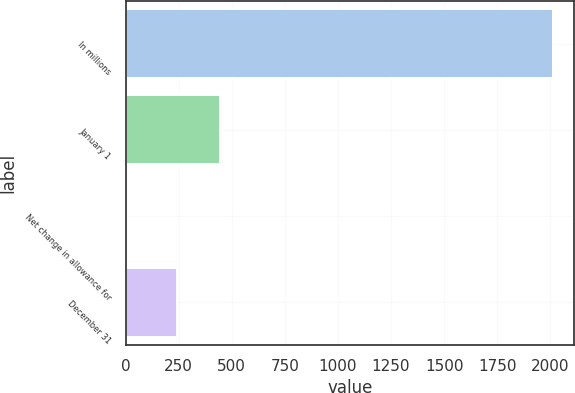<chart> <loc_0><loc_0><loc_500><loc_500><bar_chart><fcel>In millions<fcel>January 1<fcel>Net change in allowance for<fcel>December 31<nl><fcel>2013<fcel>442.5<fcel>8<fcel>242<nl></chart> 